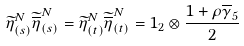<formula> <loc_0><loc_0><loc_500><loc_500>\widetilde { \eta } ^ { N } _ { ( s ) } \widetilde { \overline { \eta } } ^ { N } _ { ( s ) } = \widetilde { \eta } ^ { N } _ { ( t ) } \widetilde { \overline { \eta } } ^ { N } _ { ( t ) } = 1 _ { 2 } \otimes \frac { 1 + \rho \overline { \gamma } _ { 5 } } { 2 }</formula> 